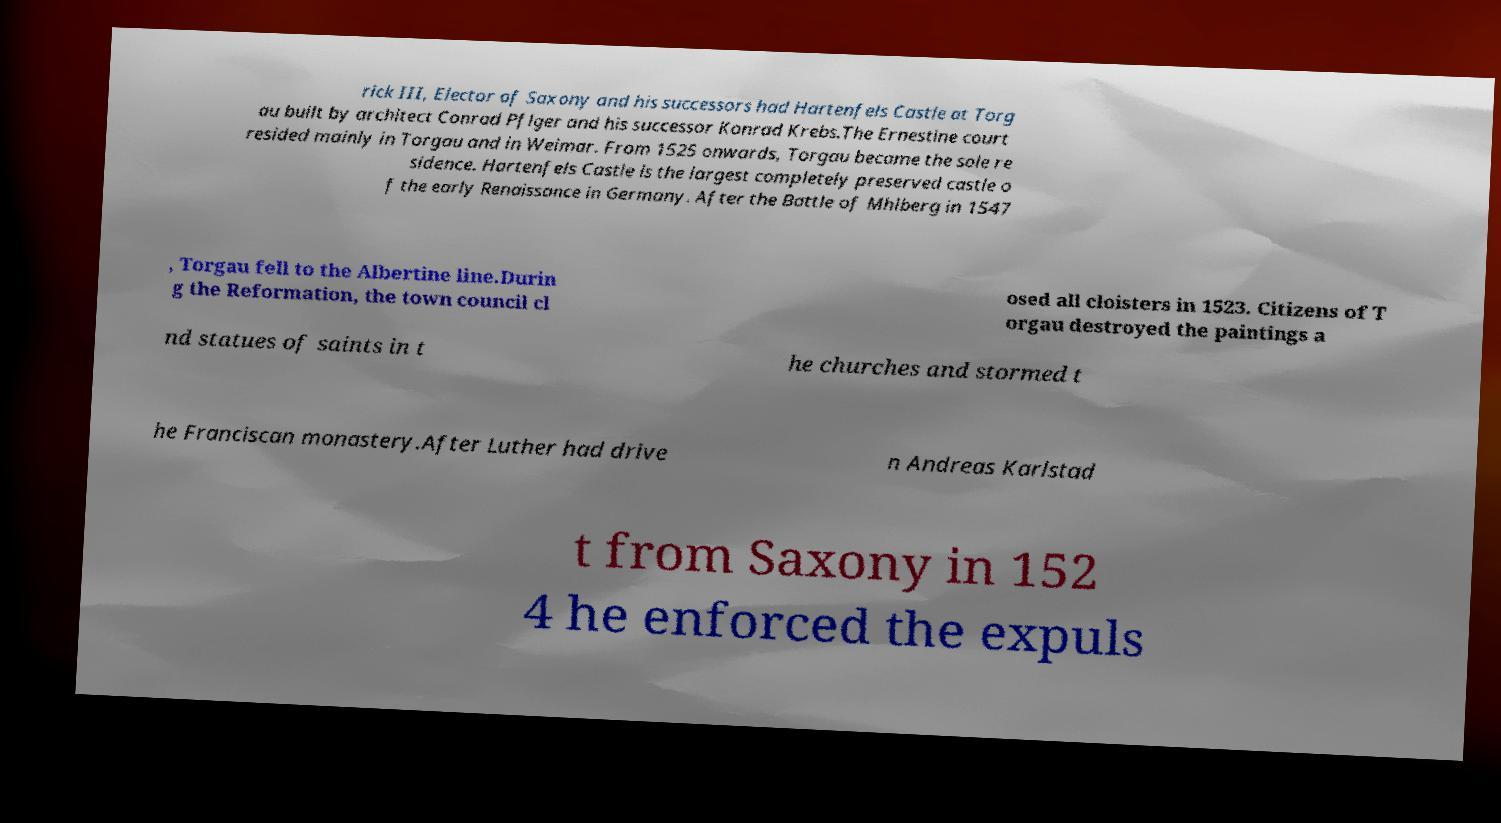Can you read and provide the text displayed in the image?This photo seems to have some interesting text. Can you extract and type it out for me? rick III, Elector of Saxony and his successors had Hartenfels Castle at Torg au built by architect Conrad Pflger and his successor Konrad Krebs.The Ernestine court resided mainly in Torgau and in Weimar. From 1525 onwards, Torgau became the sole re sidence. Hartenfels Castle is the largest completely preserved castle o f the early Renaissance in Germany. After the Battle of Mhlberg in 1547 , Torgau fell to the Albertine line.Durin g the Reformation, the town council cl osed all cloisters in 1523. Citizens of T orgau destroyed the paintings a nd statues of saints in t he churches and stormed t he Franciscan monastery.After Luther had drive n Andreas Karlstad t from Saxony in 152 4 he enforced the expuls 